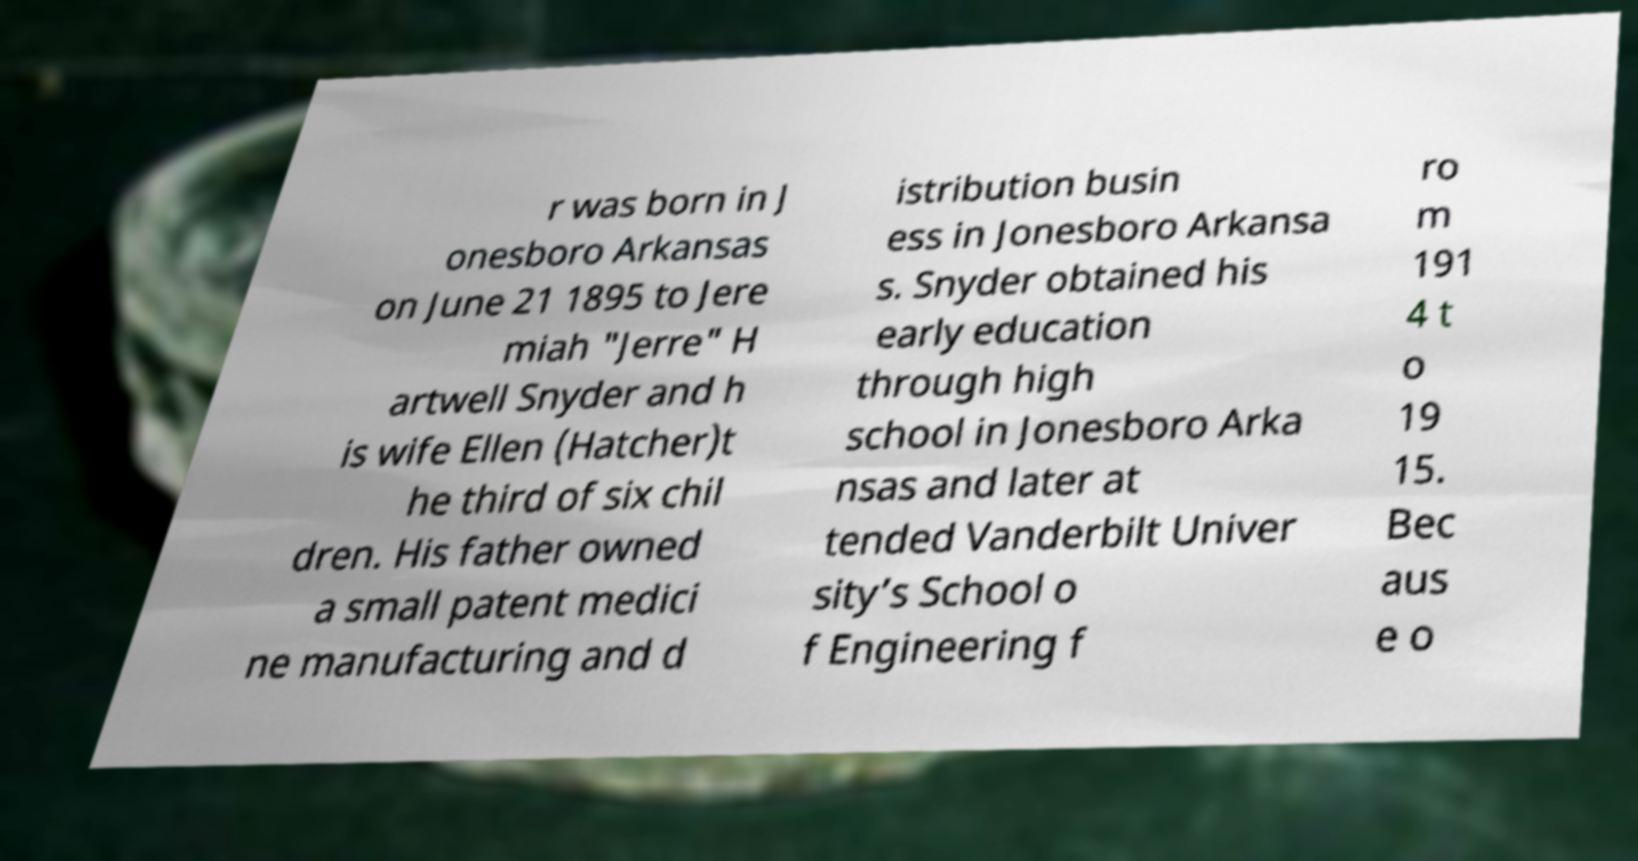What messages or text are displayed in this image? I need them in a readable, typed format. r was born in J onesboro Arkansas on June 21 1895 to Jere miah "Jerre" H artwell Snyder and h is wife Ellen (Hatcher)t he third of six chil dren. His father owned a small patent medici ne manufacturing and d istribution busin ess in Jonesboro Arkansa s. Snyder obtained his early education through high school in Jonesboro Arka nsas and later at tended Vanderbilt Univer sity’s School o f Engineering f ro m 191 4 t o 19 15. Bec aus e o 